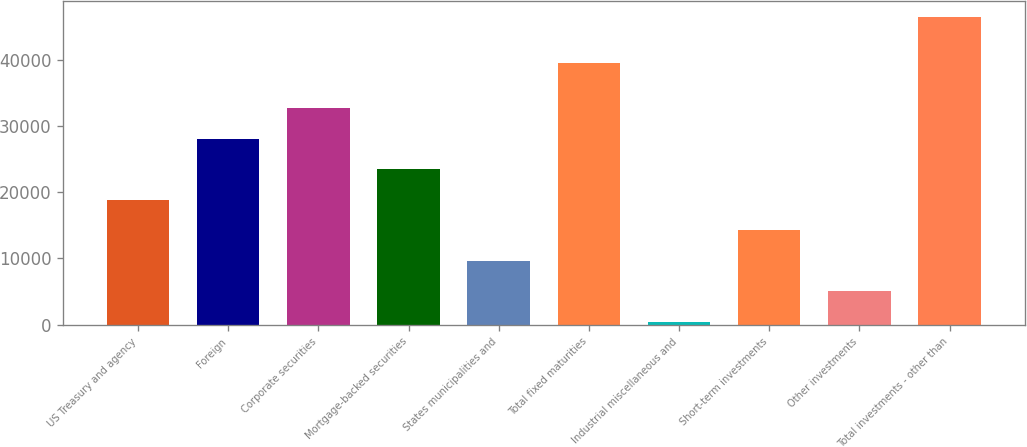<chart> <loc_0><loc_0><loc_500><loc_500><bar_chart><fcel>US Treasury and agency<fcel>Foreign<fcel>Corporate securities<fcel>Mortgage-backed securities<fcel>States municipalities and<fcel>Total fixed maturities<fcel>Industrial miscellaneous and<fcel>Short-term investments<fcel>Other investments<fcel>Total investments - other than<nl><fcel>18886.2<fcel>28095.8<fcel>32700.6<fcel>23491<fcel>9676.6<fcel>39525<fcel>467<fcel>14281.4<fcel>5071.8<fcel>46515<nl></chart> 